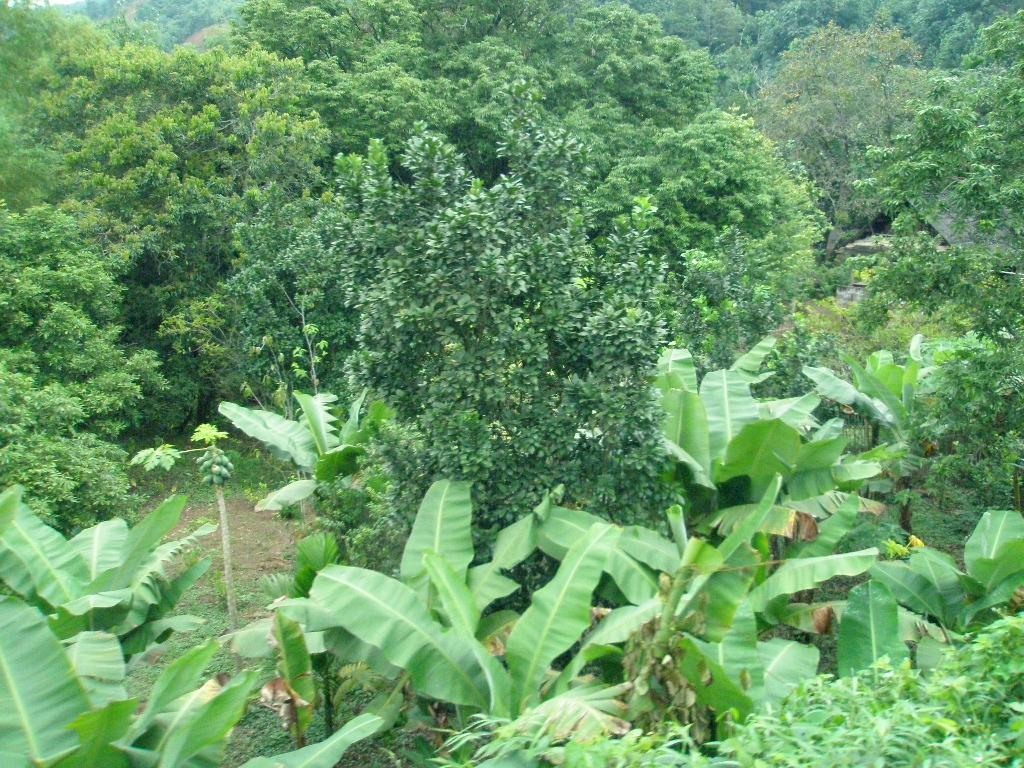What type of vegetation can be seen in the image? There are trees in the image. What part of the sister's decision can be seen in the image? There is no reference to a sister or a decision in the image, as it only features trees. 